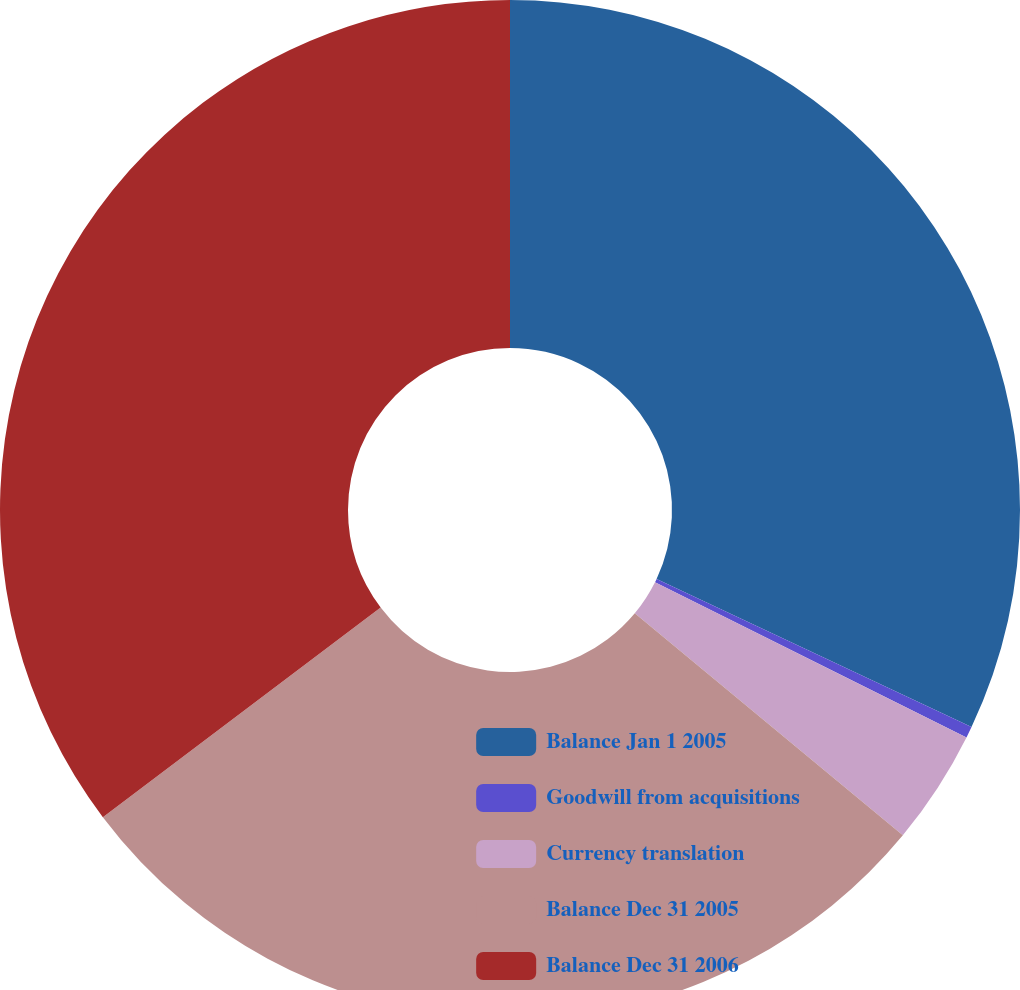Convert chart. <chart><loc_0><loc_0><loc_500><loc_500><pie_chart><fcel>Balance Jan 1 2005<fcel>Goodwill from acquisitions<fcel>Currency translation<fcel>Balance Dec 31 2005<fcel>Balance Dec 31 2006<nl><fcel>32.0%<fcel>0.36%<fcel>3.65%<fcel>28.71%<fcel>35.29%<nl></chart> 